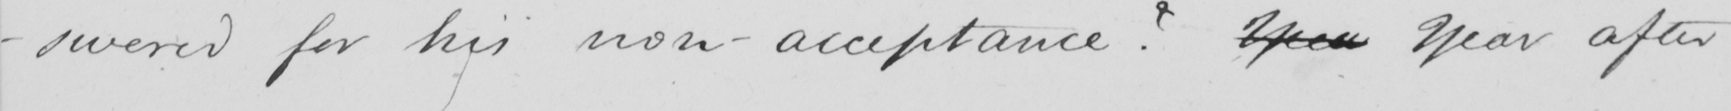Can you tell me what this handwritten text says? swered for his non-acceptance ?  Yeer Year after 